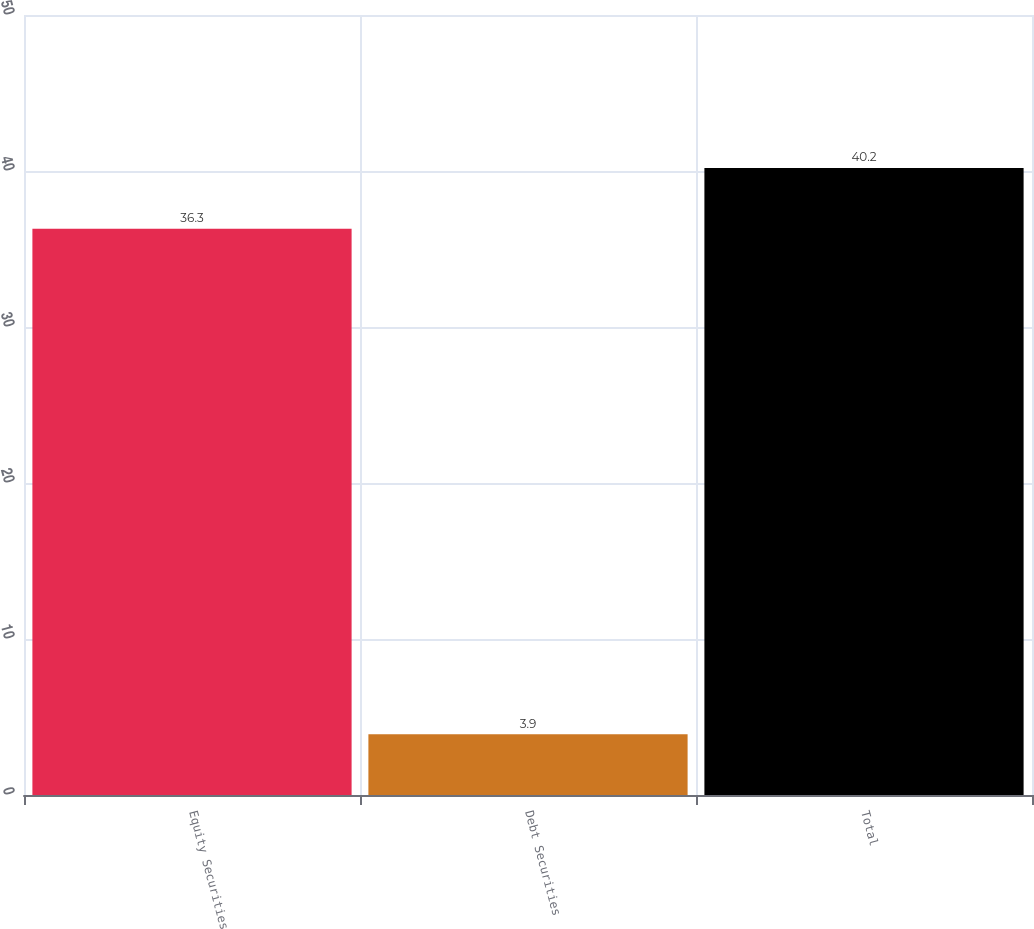<chart> <loc_0><loc_0><loc_500><loc_500><bar_chart><fcel>Equity Securities<fcel>Debt Securities<fcel>Total<nl><fcel>36.3<fcel>3.9<fcel>40.2<nl></chart> 